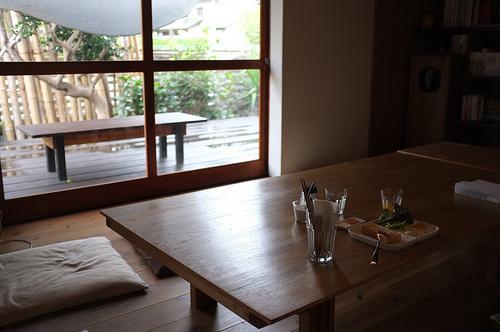How many pillows are there?
Give a very brief answer. 2. 